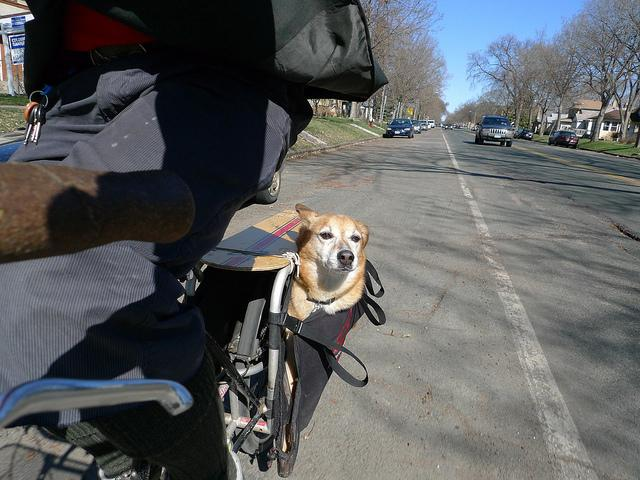How is the dog probably traveling? Please explain your reasoning. bike. Here we see a dog in a small compartment which is attached to the back of a bicycle. 